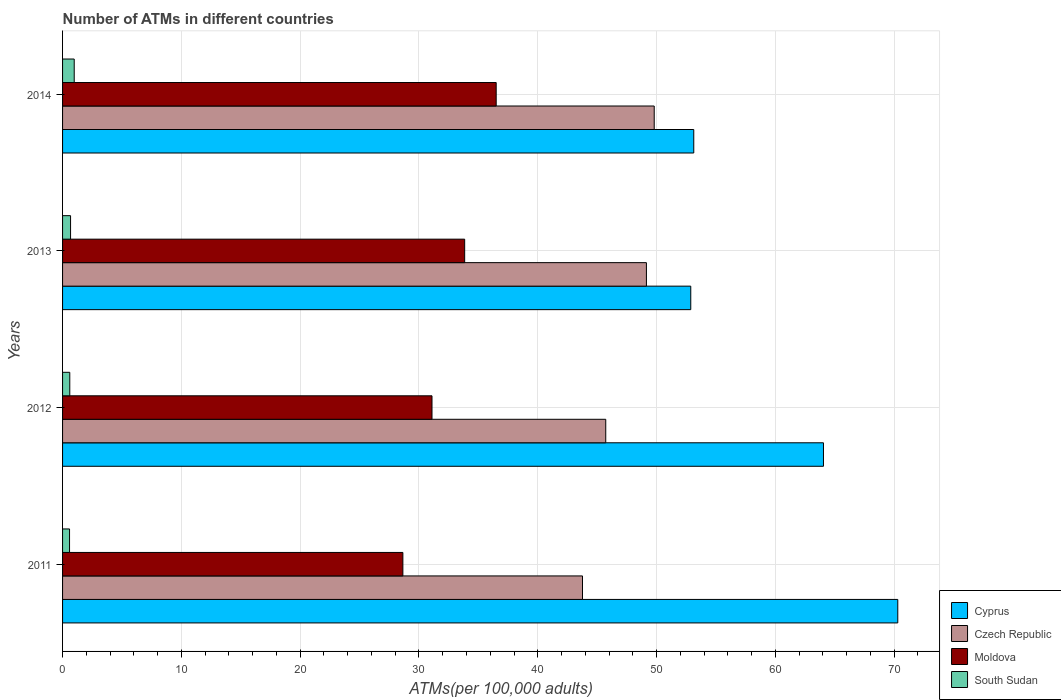How many groups of bars are there?
Keep it short and to the point. 4. Are the number of bars per tick equal to the number of legend labels?
Offer a terse response. Yes. Are the number of bars on each tick of the Y-axis equal?
Keep it short and to the point. Yes. How many bars are there on the 4th tick from the bottom?
Offer a terse response. 4. What is the label of the 1st group of bars from the top?
Give a very brief answer. 2014. What is the number of ATMs in Moldova in 2011?
Provide a short and direct response. 28.64. Across all years, what is the maximum number of ATMs in South Sudan?
Keep it short and to the point. 0.98. Across all years, what is the minimum number of ATMs in South Sudan?
Provide a short and direct response. 0.59. In which year was the number of ATMs in South Sudan maximum?
Your answer should be very brief. 2014. In which year was the number of ATMs in Czech Republic minimum?
Make the answer very short. 2011. What is the total number of ATMs in South Sudan in the graph?
Offer a very short reply. 2.85. What is the difference between the number of ATMs in Cyprus in 2011 and that in 2012?
Your answer should be compact. 6.25. What is the difference between the number of ATMs in Cyprus in 2011 and the number of ATMs in South Sudan in 2012?
Your answer should be compact. 69.69. What is the average number of ATMs in Czech Republic per year?
Your answer should be compact. 47.11. In the year 2014, what is the difference between the number of ATMs in Moldova and number of ATMs in Czech Republic?
Provide a short and direct response. -13.3. What is the ratio of the number of ATMs in South Sudan in 2011 to that in 2013?
Your answer should be very brief. 0.87. Is the number of ATMs in Moldova in 2011 less than that in 2013?
Ensure brevity in your answer.  Yes. Is the difference between the number of ATMs in Moldova in 2012 and 2013 greater than the difference between the number of ATMs in Czech Republic in 2012 and 2013?
Your answer should be compact. Yes. What is the difference between the highest and the second highest number of ATMs in Czech Republic?
Provide a short and direct response. 0.66. What is the difference between the highest and the lowest number of ATMs in Cyprus?
Your answer should be compact. 17.42. In how many years, is the number of ATMs in South Sudan greater than the average number of ATMs in South Sudan taken over all years?
Your response must be concise. 1. Is the sum of the number of ATMs in Czech Republic in 2012 and 2014 greater than the maximum number of ATMs in Cyprus across all years?
Make the answer very short. Yes. What does the 2nd bar from the top in 2013 represents?
Your answer should be very brief. Moldova. What does the 4th bar from the bottom in 2013 represents?
Your answer should be very brief. South Sudan. Is it the case that in every year, the sum of the number of ATMs in South Sudan and number of ATMs in Czech Republic is greater than the number of ATMs in Moldova?
Provide a short and direct response. Yes. Are all the bars in the graph horizontal?
Keep it short and to the point. Yes. How many years are there in the graph?
Offer a very short reply. 4. Are the values on the major ticks of X-axis written in scientific E-notation?
Your response must be concise. No. Does the graph contain any zero values?
Ensure brevity in your answer.  No. Does the graph contain grids?
Your response must be concise. Yes. How many legend labels are there?
Provide a succinct answer. 4. What is the title of the graph?
Offer a very short reply. Number of ATMs in different countries. Does "High income: nonOECD" appear as one of the legend labels in the graph?
Your answer should be compact. No. What is the label or title of the X-axis?
Keep it short and to the point. ATMs(per 100,0 adults). What is the ATMs(per 100,000 adults) in Cyprus in 2011?
Give a very brief answer. 70.3. What is the ATMs(per 100,000 adults) in Czech Republic in 2011?
Your response must be concise. 43.76. What is the ATMs(per 100,000 adults) of Moldova in 2011?
Offer a very short reply. 28.64. What is the ATMs(per 100,000 adults) of South Sudan in 2011?
Ensure brevity in your answer.  0.59. What is the ATMs(per 100,000 adults) in Cyprus in 2012?
Give a very brief answer. 64.04. What is the ATMs(per 100,000 adults) of Czech Republic in 2012?
Offer a very short reply. 45.72. What is the ATMs(per 100,000 adults) of Moldova in 2012?
Ensure brevity in your answer.  31.1. What is the ATMs(per 100,000 adults) in South Sudan in 2012?
Your response must be concise. 0.61. What is the ATMs(per 100,000 adults) of Cyprus in 2013?
Make the answer very short. 52.88. What is the ATMs(per 100,000 adults) in Czech Republic in 2013?
Provide a succinct answer. 49.14. What is the ATMs(per 100,000 adults) in Moldova in 2013?
Your answer should be very brief. 33.84. What is the ATMs(per 100,000 adults) of South Sudan in 2013?
Offer a very short reply. 0.67. What is the ATMs(per 100,000 adults) in Cyprus in 2014?
Give a very brief answer. 53.13. What is the ATMs(per 100,000 adults) in Czech Republic in 2014?
Provide a short and direct response. 49.8. What is the ATMs(per 100,000 adults) in Moldova in 2014?
Keep it short and to the point. 36.5. What is the ATMs(per 100,000 adults) in South Sudan in 2014?
Your answer should be very brief. 0.98. Across all years, what is the maximum ATMs(per 100,000 adults) of Cyprus?
Ensure brevity in your answer.  70.3. Across all years, what is the maximum ATMs(per 100,000 adults) in Czech Republic?
Provide a short and direct response. 49.8. Across all years, what is the maximum ATMs(per 100,000 adults) of Moldova?
Your response must be concise. 36.5. Across all years, what is the maximum ATMs(per 100,000 adults) of South Sudan?
Give a very brief answer. 0.98. Across all years, what is the minimum ATMs(per 100,000 adults) of Cyprus?
Make the answer very short. 52.88. Across all years, what is the minimum ATMs(per 100,000 adults) in Czech Republic?
Give a very brief answer. 43.76. Across all years, what is the minimum ATMs(per 100,000 adults) in Moldova?
Offer a terse response. 28.64. Across all years, what is the minimum ATMs(per 100,000 adults) of South Sudan?
Your response must be concise. 0.59. What is the total ATMs(per 100,000 adults) of Cyprus in the graph?
Your answer should be very brief. 240.35. What is the total ATMs(per 100,000 adults) in Czech Republic in the graph?
Offer a terse response. 188.42. What is the total ATMs(per 100,000 adults) in Moldova in the graph?
Ensure brevity in your answer.  130.08. What is the total ATMs(per 100,000 adults) in South Sudan in the graph?
Offer a very short reply. 2.85. What is the difference between the ATMs(per 100,000 adults) of Cyprus in 2011 and that in 2012?
Provide a short and direct response. 6.25. What is the difference between the ATMs(per 100,000 adults) of Czech Republic in 2011 and that in 2012?
Make the answer very short. -1.96. What is the difference between the ATMs(per 100,000 adults) in Moldova in 2011 and that in 2012?
Offer a terse response. -2.45. What is the difference between the ATMs(per 100,000 adults) of South Sudan in 2011 and that in 2012?
Your response must be concise. -0.02. What is the difference between the ATMs(per 100,000 adults) in Cyprus in 2011 and that in 2013?
Your answer should be compact. 17.42. What is the difference between the ATMs(per 100,000 adults) of Czech Republic in 2011 and that in 2013?
Provide a short and direct response. -5.38. What is the difference between the ATMs(per 100,000 adults) in Moldova in 2011 and that in 2013?
Ensure brevity in your answer.  -5.2. What is the difference between the ATMs(per 100,000 adults) in South Sudan in 2011 and that in 2013?
Your answer should be very brief. -0.09. What is the difference between the ATMs(per 100,000 adults) in Cyprus in 2011 and that in 2014?
Ensure brevity in your answer.  17.17. What is the difference between the ATMs(per 100,000 adults) of Czech Republic in 2011 and that in 2014?
Your response must be concise. -6.04. What is the difference between the ATMs(per 100,000 adults) in Moldova in 2011 and that in 2014?
Keep it short and to the point. -7.85. What is the difference between the ATMs(per 100,000 adults) of South Sudan in 2011 and that in 2014?
Offer a very short reply. -0.39. What is the difference between the ATMs(per 100,000 adults) of Cyprus in 2012 and that in 2013?
Give a very brief answer. 11.17. What is the difference between the ATMs(per 100,000 adults) of Czech Republic in 2012 and that in 2013?
Ensure brevity in your answer.  -3.42. What is the difference between the ATMs(per 100,000 adults) of Moldova in 2012 and that in 2013?
Make the answer very short. -2.75. What is the difference between the ATMs(per 100,000 adults) of South Sudan in 2012 and that in 2013?
Offer a very short reply. -0.07. What is the difference between the ATMs(per 100,000 adults) in Cyprus in 2012 and that in 2014?
Make the answer very short. 10.92. What is the difference between the ATMs(per 100,000 adults) of Czech Republic in 2012 and that in 2014?
Provide a short and direct response. -4.08. What is the difference between the ATMs(per 100,000 adults) in Moldova in 2012 and that in 2014?
Offer a very short reply. -5.4. What is the difference between the ATMs(per 100,000 adults) in South Sudan in 2012 and that in 2014?
Offer a very short reply. -0.37. What is the difference between the ATMs(per 100,000 adults) of Cyprus in 2013 and that in 2014?
Give a very brief answer. -0.25. What is the difference between the ATMs(per 100,000 adults) in Czech Republic in 2013 and that in 2014?
Your answer should be compact. -0.66. What is the difference between the ATMs(per 100,000 adults) in Moldova in 2013 and that in 2014?
Offer a very short reply. -2.65. What is the difference between the ATMs(per 100,000 adults) of South Sudan in 2013 and that in 2014?
Your answer should be compact. -0.31. What is the difference between the ATMs(per 100,000 adults) of Cyprus in 2011 and the ATMs(per 100,000 adults) of Czech Republic in 2012?
Give a very brief answer. 24.58. What is the difference between the ATMs(per 100,000 adults) of Cyprus in 2011 and the ATMs(per 100,000 adults) of Moldova in 2012?
Ensure brevity in your answer.  39.2. What is the difference between the ATMs(per 100,000 adults) of Cyprus in 2011 and the ATMs(per 100,000 adults) of South Sudan in 2012?
Your answer should be compact. 69.69. What is the difference between the ATMs(per 100,000 adults) of Czech Republic in 2011 and the ATMs(per 100,000 adults) of Moldova in 2012?
Provide a short and direct response. 12.67. What is the difference between the ATMs(per 100,000 adults) of Czech Republic in 2011 and the ATMs(per 100,000 adults) of South Sudan in 2012?
Your answer should be compact. 43.15. What is the difference between the ATMs(per 100,000 adults) in Moldova in 2011 and the ATMs(per 100,000 adults) in South Sudan in 2012?
Give a very brief answer. 28.04. What is the difference between the ATMs(per 100,000 adults) in Cyprus in 2011 and the ATMs(per 100,000 adults) in Czech Republic in 2013?
Make the answer very short. 21.16. What is the difference between the ATMs(per 100,000 adults) of Cyprus in 2011 and the ATMs(per 100,000 adults) of Moldova in 2013?
Your answer should be compact. 36.45. What is the difference between the ATMs(per 100,000 adults) of Cyprus in 2011 and the ATMs(per 100,000 adults) of South Sudan in 2013?
Offer a very short reply. 69.63. What is the difference between the ATMs(per 100,000 adults) of Czech Republic in 2011 and the ATMs(per 100,000 adults) of Moldova in 2013?
Provide a short and direct response. 9.92. What is the difference between the ATMs(per 100,000 adults) in Czech Republic in 2011 and the ATMs(per 100,000 adults) in South Sudan in 2013?
Offer a terse response. 43.09. What is the difference between the ATMs(per 100,000 adults) in Moldova in 2011 and the ATMs(per 100,000 adults) in South Sudan in 2013?
Ensure brevity in your answer.  27.97. What is the difference between the ATMs(per 100,000 adults) in Cyprus in 2011 and the ATMs(per 100,000 adults) in Moldova in 2014?
Make the answer very short. 33.8. What is the difference between the ATMs(per 100,000 adults) of Cyprus in 2011 and the ATMs(per 100,000 adults) of South Sudan in 2014?
Your response must be concise. 69.32. What is the difference between the ATMs(per 100,000 adults) in Czech Republic in 2011 and the ATMs(per 100,000 adults) in Moldova in 2014?
Keep it short and to the point. 7.26. What is the difference between the ATMs(per 100,000 adults) of Czech Republic in 2011 and the ATMs(per 100,000 adults) of South Sudan in 2014?
Offer a very short reply. 42.78. What is the difference between the ATMs(per 100,000 adults) of Moldova in 2011 and the ATMs(per 100,000 adults) of South Sudan in 2014?
Make the answer very short. 27.66. What is the difference between the ATMs(per 100,000 adults) in Cyprus in 2012 and the ATMs(per 100,000 adults) in Czech Republic in 2013?
Make the answer very short. 14.9. What is the difference between the ATMs(per 100,000 adults) of Cyprus in 2012 and the ATMs(per 100,000 adults) of Moldova in 2013?
Provide a succinct answer. 30.2. What is the difference between the ATMs(per 100,000 adults) in Cyprus in 2012 and the ATMs(per 100,000 adults) in South Sudan in 2013?
Provide a short and direct response. 63.37. What is the difference between the ATMs(per 100,000 adults) in Czech Republic in 2012 and the ATMs(per 100,000 adults) in Moldova in 2013?
Offer a very short reply. 11.88. What is the difference between the ATMs(per 100,000 adults) in Czech Republic in 2012 and the ATMs(per 100,000 adults) in South Sudan in 2013?
Make the answer very short. 45.05. What is the difference between the ATMs(per 100,000 adults) in Moldova in 2012 and the ATMs(per 100,000 adults) in South Sudan in 2013?
Offer a very short reply. 30.42. What is the difference between the ATMs(per 100,000 adults) in Cyprus in 2012 and the ATMs(per 100,000 adults) in Czech Republic in 2014?
Provide a short and direct response. 14.25. What is the difference between the ATMs(per 100,000 adults) in Cyprus in 2012 and the ATMs(per 100,000 adults) in Moldova in 2014?
Give a very brief answer. 27.55. What is the difference between the ATMs(per 100,000 adults) in Cyprus in 2012 and the ATMs(per 100,000 adults) in South Sudan in 2014?
Your response must be concise. 63.06. What is the difference between the ATMs(per 100,000 adults) in Czech Republic in 2012 and the ATMs(per 100,000 adults) in Moldova in 2014?
Provide a succinct answer. 9.22. What is the difference between the ATMs(per 100,000 adults) of Czech Republic in 2012 and the ATMs(per 100,000 adults) of South Sudan in 2014?
Offer a very short reply. 44.74. What is the difference between the ATMs(per 100,000 adults) of Moldova in 2012 and the ATMs(per 100,000 adults) of South Sudan in 2014?
Your response must be concise. 30.11. What is the difference between the ATMs(per 100,000 adults) in Cyprus in 2013 and the ATMs(per 100,000 adults) in Czech Republic in 2014?
Offer a very short reply. 3.08. What is the difference between the ATMs(per 100,000 adults) in Cyprus in 2013 and the ATMs(per 100,000 adults) in Moldova in 2014?
Offer a very short reply. 16.38. What is the difference between the ATMs(per 100,000 adults) in Cyprus in 2013 and the ATMs(per 100,000 adults) in South Sudan in 2014?
Provide a short and direct response. 51.89. What is the difference between the ATMs(per 100,000 adults) in Czech Republic in 2013 and the ATMs(per 100,000 adults) in Moldova in 2014?
Keep it short and to the point. 12.64. What is the difference between the ATMs(per 100,000 adults) in Czech Republic in 2013 and the ATMs(per 100,000 adults) in South Sudan in 2014?
Offer a very short reply. 48.16. What is the difference between the ATMs(per 100,000 adults) in Moldova in 2013 and the ATMs(per 100,000 adults) in South Sudan in 2014?
Ensure brevity in your answer.  32.86. What is the average ATMs(per 100,000 adults) of Cyprus per year?
Your answer should be compact. 60.09. What is the average ATMs(per 100,000 adults) of Czech Republic per year?
Provide a succinct answer. 47.11. What is the average ATMs(per 100,000 adults) in Moldova per year?
Offer a very short reply. 32.52. What is the average ATMs(per 100,000 adults) of South Sudan per year?
Keep it short and to the point. 0.71. In the year 2011, what is the difference between the ATMs(per 100,000 adults) in Cyprus and ATMs(per 100,000 adults) in Czech Republic?
Keep it short and to the point. 26.54. In the year 2011, what is the difference between the ATMs(per 100,000 adults) of Cyprus and ATMs(per 100,000 adults) of Moldova?
Keep it short and to the point. 41.66. In the year 2011, what is the difference between the ATMs(per 100,000 adults) of Cyprus and ATMs(per 100,000 adults) of South Sudan?
Your answer should be compact. 69.71. In the year 2011, what is the difference between the ATMs(per 100,000 adults) in Czech Republic and ATMs(per 100,000 adults) in Moldova?
Ensure brevity in your answer.  15.12. In the year 2011, what is the difference between the ATMs(per 100,000 adults) of Czech Republic and ATMs(per 100,000 adults) of South Sudan?
Make the answer very short. 43.18. In the year 2011, what is the difference between the ATMs(per 100,000 adults) of Moldova and ATMs(per 100,000 adults) of South Sudan?
Make the answer very short. 28.06. In the year 2012, what is the difference between the ATMs(per 100,000 adults) of Cyprus and ATMs(per 100,000 adults) of Czech Republic?
Give a very brief answer. 18.32. In the year 2012, what is the difference between the ATMs(per 100,000 adults) in Cyprus and ATMs(per 100,000 adults) in Moldova?
Give a very brief answer. 32.95. In the year 2012, what is the difference between the ATMs(per 100,000 adults) in Cyprus and ATMs(per 100,000 adults) in South Sudan?
Offer a terse response. 63.44. In the year 2012, what is the difference between the ATMs(per 100,000 adults) in Czech Republic and ATMs(per 100,000 adults) in Moldova?
Give a very brief answer. 14.62. In the year 2012, what is the difference between the ATMs(per 100,000 adults) of Czech Republic and ATMs(per 100,000 adults) of South Sudan?
Provide a short and direct response. 45.11. In the year 2012, what is the difference between the ATMs(per 100,000 adults) in Moldova and ATMs(per 100,000 adults) in South Sudan?
Ensure brevity in your answer.  30.49. In the year 2013, what is the difference between the ATMs(per 100,000 adults) of Cyprus and ATMs(per 100,000 adults) of Czech Republic?
Give a very brief answer. 3.73. In the year 2013, what is the difference between the ATMs(per 100,000 adults) of Cyprus and ATMs(per 100,000 adults) of Moldova?
Make the answer very short. 19.03. In the year 2013, what is the difference between the ATMs(per 100,000 adults) in Cyprus and ATMs(per 100,000 adults) in South Sudan?
Your answer should be compact. 52.2. In the year 2013, what is the difference between the ATMs(per 100,000 adults) of Czech Republic and ATMs(per 100,000 adults) of Moldova?
Give a very brief answer. 15.3. In the year 2013, what is the difference between the ATMs(per 100,000 adults) in Czech Republic and ATMs(per 100,000 adults) in South Sudan?
Ensure brevity in your answer.  48.47. In the year 2013, what is the difference between the ATMs(per 100,000 adults) in Moldova and ATMs(per 100,000 adults) in South Sudan?
Your answer should be very brief. 33.17. In the year 2014, what is the difference between the ATMs(per 100,000 adults) of Cyprus and ATMs(per 100,000 adults) of Czech Republic?
Your answer should be very brief. 3.33. In the year 2014, what is the difference between the ATMs(per 100,000 adults) of Cyprus and ATMs(per 100,000 adults) of Moldova?
Your answer should be compact. 16.63. In the year 2014, what is the difference between the ATMs(per 100,000 adults) of Cyprus and ATMs(per 100,000 adults) of South Sudan?
Provide a short and direct response. 52.15. In the year 2014, what is the difference between the ATMs(per 100,000 adults) of Czech Republic and ATMs(per 100,000 adults) of Moldova?
Your answer should be compact. 13.3. In the year 2014, what is the difference between the ATMs(per 100,000 adults) in Czech Republic and ATMs(per 100,000 adults) in South Sudan?
Ensure brevity in your answer.  48.82. In the year 2014, what is the difference between the ATMs(per 100,000 adults) in Moldova and ATMs(per 100,000 adults) in South Sudan?
Offer a terse response. 35.52. What is the ratio of the ATMs(per 100,000 adults) of Cyprus in 2011 to that in 2012?
Offer a very short reply. 1.1. What is the ratio of the ATMs(per 100,000 adults) of Czech Republic in 2011 to that in 2012?
Your response must be concise. 0.96. What is the ratio of the ATMs(per 100,000 adults) of Moldova in 2011 to that in 2012?
Provide a short and direct response. 0.92. What is the ratio of the ATMs(per 100,000 adults) in South Sudan in 2011 to that in 2012?
Keep it short and to the point. 0.97. What is the ratio of the ATMs(per 100,000 adults) in Cyprus in 2011 to that in 2013?
Provide a short and direct response. 1.33. What is the ratio of the ATMs(per 100,000 adults) of Czech Republic in 2011 to that in 2013?
Give a very brief answer. 0.89. What is the ratio of the ATMs(per 100,000 adults) of Moldova in 2011 to that in 2013?
Offer a very short reply. 0.85. What is the ratio of the ATMs(per 100,000 adults) of South Sudan in 2011 to that in 2013?
Your response must be concise. 0.87. What is the ratio of the ATMs(per 100,000 adults) in Cyprus in 2011 to that in 2014?
Keep it short and to the point. 1.32. What is the ratio of the ATMs(per 100,000 adults) in Czech Republic in 2011 to that in 2014?
Your answer should be very brief. 0.88. What is the ratio of the ATMs(per 100,000 adults) of Moldova in 2011 to that in 2014?
Your answer should be very brief. 0.78. What is the ratio of the ATMs(per 100,000 adults) of South Sudan in 2011 to that in 2014?
Offer a terse response. 0.6. What is the ratio of the ATMs(per 100,000 adults) of Cyprus in 2012 to that in 2013?
Offer a very short reply. 1.21. What is the ratio of the ATMs(per 100,000 adults) in Czech Republic in 2012 to that in 2013?
Your answer should be compact. 0.93. What is the ratio of the ATMs(per 100,000 adults) of Moldova in 2012 to that in 2013?
Keep it short and to the point. 0.92. What is the ratio of the ATMs(per 100,000 adults) of South Sudan in 2012 to that in 2013?
Ensure brevity in your answer.  0.9. What is the ratio of the ATMs(per 100,000 adults) in Cyprus in 2012 to that in 2014?
Your response must be concise. 1.21. What is the ratio of the ATMs(per 100,000 adults) in Czech Republic in 2012 to that in 2014?
Your answer should be very brief. 0.92. What is the ratio of the ATMs(per 100,000 adults) of Moldova in 2012 to that in 2014?
Give a very brief answer. 0.85. What is the ratio of the ATMs(per 100,000 adults) of South Sudan in 2012 to that in 2014?
Give a very brief answer. 0.62. What is the ratio of the ATMs(per 100,000 adults) of Moldova in 2013 to that in 2014?
Provide a short and direct response. 0.93. What is the ratio of the ATMs(per 100,000 adults) in South Sudan in 2013 to that in 2014?
Offer a very short reply. 0.69. What is the difference between the highest and the second highest ATMs(per 100,000 adults) of Cyprus?
Offer a terse response. 6.25. What is the difference between the highest and the second highest ATMs(per 100,000 adults) of Czech Republic?
Give a very brief answer. 0.66. What is the difference between the highest and the second highest ATMs(per 100,000 adults) of Moldova?
Provide a succinct answer. 2.65. What is the difference between the highest and the second highest ATMs(per 100,000 adults) of South Sudan?
Offer a very short reply. 0.31. What is the difference between the highest and the lowest ATMs(per 100,000 adults) in Cyprus?
Offer a very short reply. 17.42. What is the difference between the highest and the lowest ATMs(per 100,000 adults) in Czech Republic?
Make the answer very short. 6.04. What is the difference between the highest and the lowest ATMs(per 100,000 adults) of Moldova?
Keep it short and to the point. 7.85. What is the difference between the highest and the lowest ATMs(per 100,000 adults) of South Sudan?
Provide a short and direct response. 0.39. 